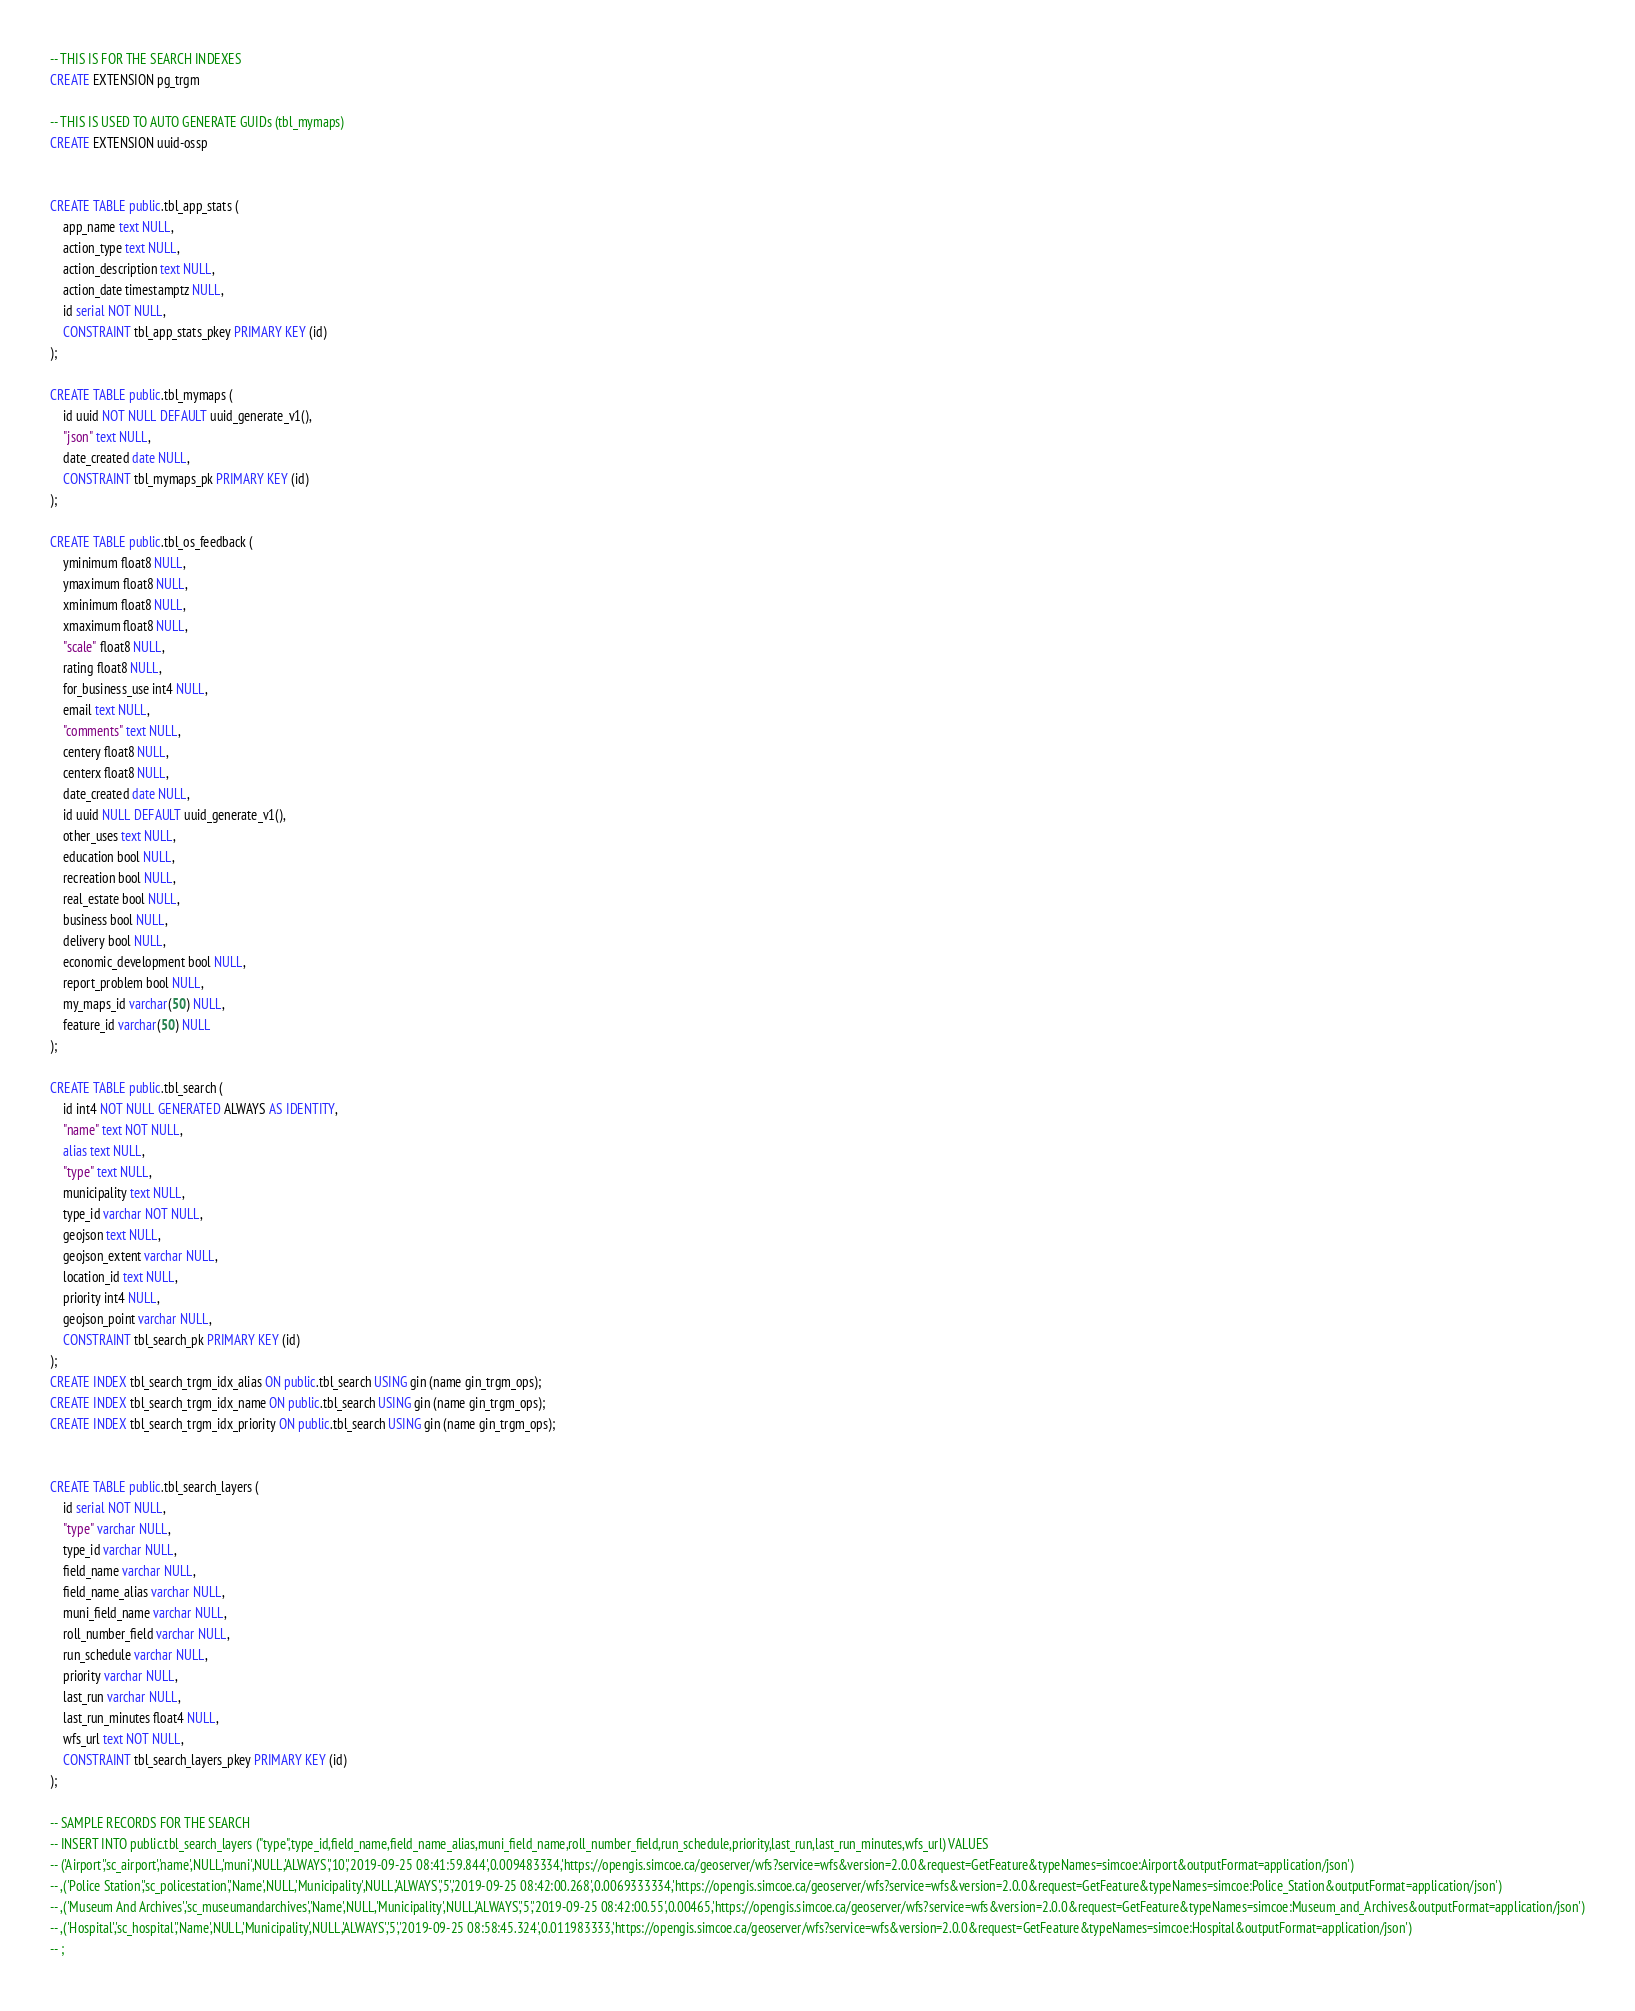<code> <loc_0><loc_0><loc_500><loc_500><_SQL_>
-- THIS IS FOR THE SEARCH INDEXES
CREATE EXTENSION pg_trgm

-- THIS IS USED TO AUTO GENERATE GUIDs (tbl_mymaps)
CREATE EXTENSION uuid-ossp


CREATE TABLE public.tbl_app_stats (
	app_name text NULL,
	action_type text NULL,
	action_description text NULL,
	action_date timestamptz NULL,
	id serial NOT NULL,
	CONSTRAINT tbl_app_stats_pkey PRIMARY KEY (id)
);

CREATE TABLE public.tbl_mymaps (
	id uuid NOT NULL DEFAULT uuid_generate_v1(),
	"json" text NULL,
	date_created date NULL,
	CONSTRAINT tbl_mymaps_pk PRIMARY KEY (id)
);

CREATE TABLE public.tbl_os_feedback (
	yminimum float8 NULL,
	ymaximum float8 NULL,
	xminimum float8 NULL,
	xmaximum float8 NULL,
	"scale" float8 NULL,
	rating float8 NULL,
	for_business_use int4 NULL,
	email text NULL,
	"comments" text NULL,
	centery float8 NULL,
	centerx float8 NULL,
	date_created date NULL,
	id uuid NULL DEFAULT uuid_generate_v1(),
	other_uses text NULL,
	education bool NULL,
	recreation bool NULL,
	real_estate bool NULL,
	business bool NULL,
	delivery bool NULL,
	economic_development bool NULL,
	report_problem bool NULL,
	my_maps_id varchar(50) NULL,
	feature_id varchar(50) NULL
);

CREATE TABLE public.tbl_search (
	id int4 NOT NULL GENERATED ALWAYS AS IDENTITY,
	"name" text NOT NULL,
	alias text NULL,
	"type" text NULL,
	municipality text NULL,
	type_id varchar NOT NULL,
	geojson text NULL,
	geojson_extent varchar NULL,
	location_id text NULL,
	priority int4 NULL,
	geojson_point varchar NULL,
	CONSTRAINT tbl_search_pk PRIMARY KEY (id)
);
CREATE INDEX tbl_search_trgm_idx_alias ON public.tbl_search USING gin (name gin_trgm_ops);
CREATE INDEX tbl_search_trgm_idx_name ON public.tbl_search USING gin (name gin_trgm_ops);
CREATE INDEX tbl_search_trgm_idx_priority ON public.tbl_search USING gin (name gin_trgm_ops);


CREATE TABLE public.tbl_search_layers (
	id serial NOT NULL,
	"type" varchar NULL,
	type_id varchar NULL,
	field_name varchar NULL,
	field_name_alias varchar NULL,
	muni_field_name varchar NULL,
	roll_number_field varchar NULL,
	run_schedule varchar NULL,
	priority varchar NULL,
	last_run varchar NULL,
	last_run_minutes float4 NULL,
	wfs_url text NOT NULL,
	CONSTRAINT tbl_search_layers_pkey PRIMARY KEY (id)
);

-- SAMPLE RECORDS FOR THE SEARCH
-- INSERT INTO public.tbl_search_layers ("type",type_id,field_name,field_name_alias,muni_field_name,roll_number_field,run_schedule,priority,last_run,last_run_minutes,wfs_url) VALUES 
-- ('Airport','sc_airport','name',NULL,'muni',NULL,'ALWAYS','10','2019-09-25 08:41:59.844',0.009483334,'https://opengis.simcoe.ca/geoserver/wfs?service=wfs&version=2.0.0&request=GetFeature&typeNames=simcoe:Airport&outputFormat=application/json')
-- ,('Police Station','sc_policestation','Name',NULL,'Municipality',NULL,'ALWAYS','5','2019-09-25 08:42:00.268',0.0069333334,'https://opengis.simcoe.ca/geoserver/wfs?service=wfs&version=2.0.0&request=GetFeature&typeNames=simcoe:Police_Station&outputFormat=application/json')
-- ,('Museum And Archives','sc_museumandarchives','Name',NULL,'Municipality',NULL,'ALWAYS','5','2019-09-25 08:42:00.55',0.00465,'https://opengis.simcoe.ca/geoserver/wfs?service=wfs&version=2.0.0&request=GetFeature&typeNames=simcoe:Museum_and_Archives&outputFormat=application/json')
-- ,('Hospital','sc_hospital','Name',NULL,'Municipality',NULL,'ALWAYS','5','2019-09-25 08:58:45.324',0.011983333,'https://opengis.simcoe.ca/geoserver/wfs?service=wfs&version=2.0.0&request=GetFeature&typeNames=simcoe:Hospital&outputFormat=application/json')
-- ;

</code> 